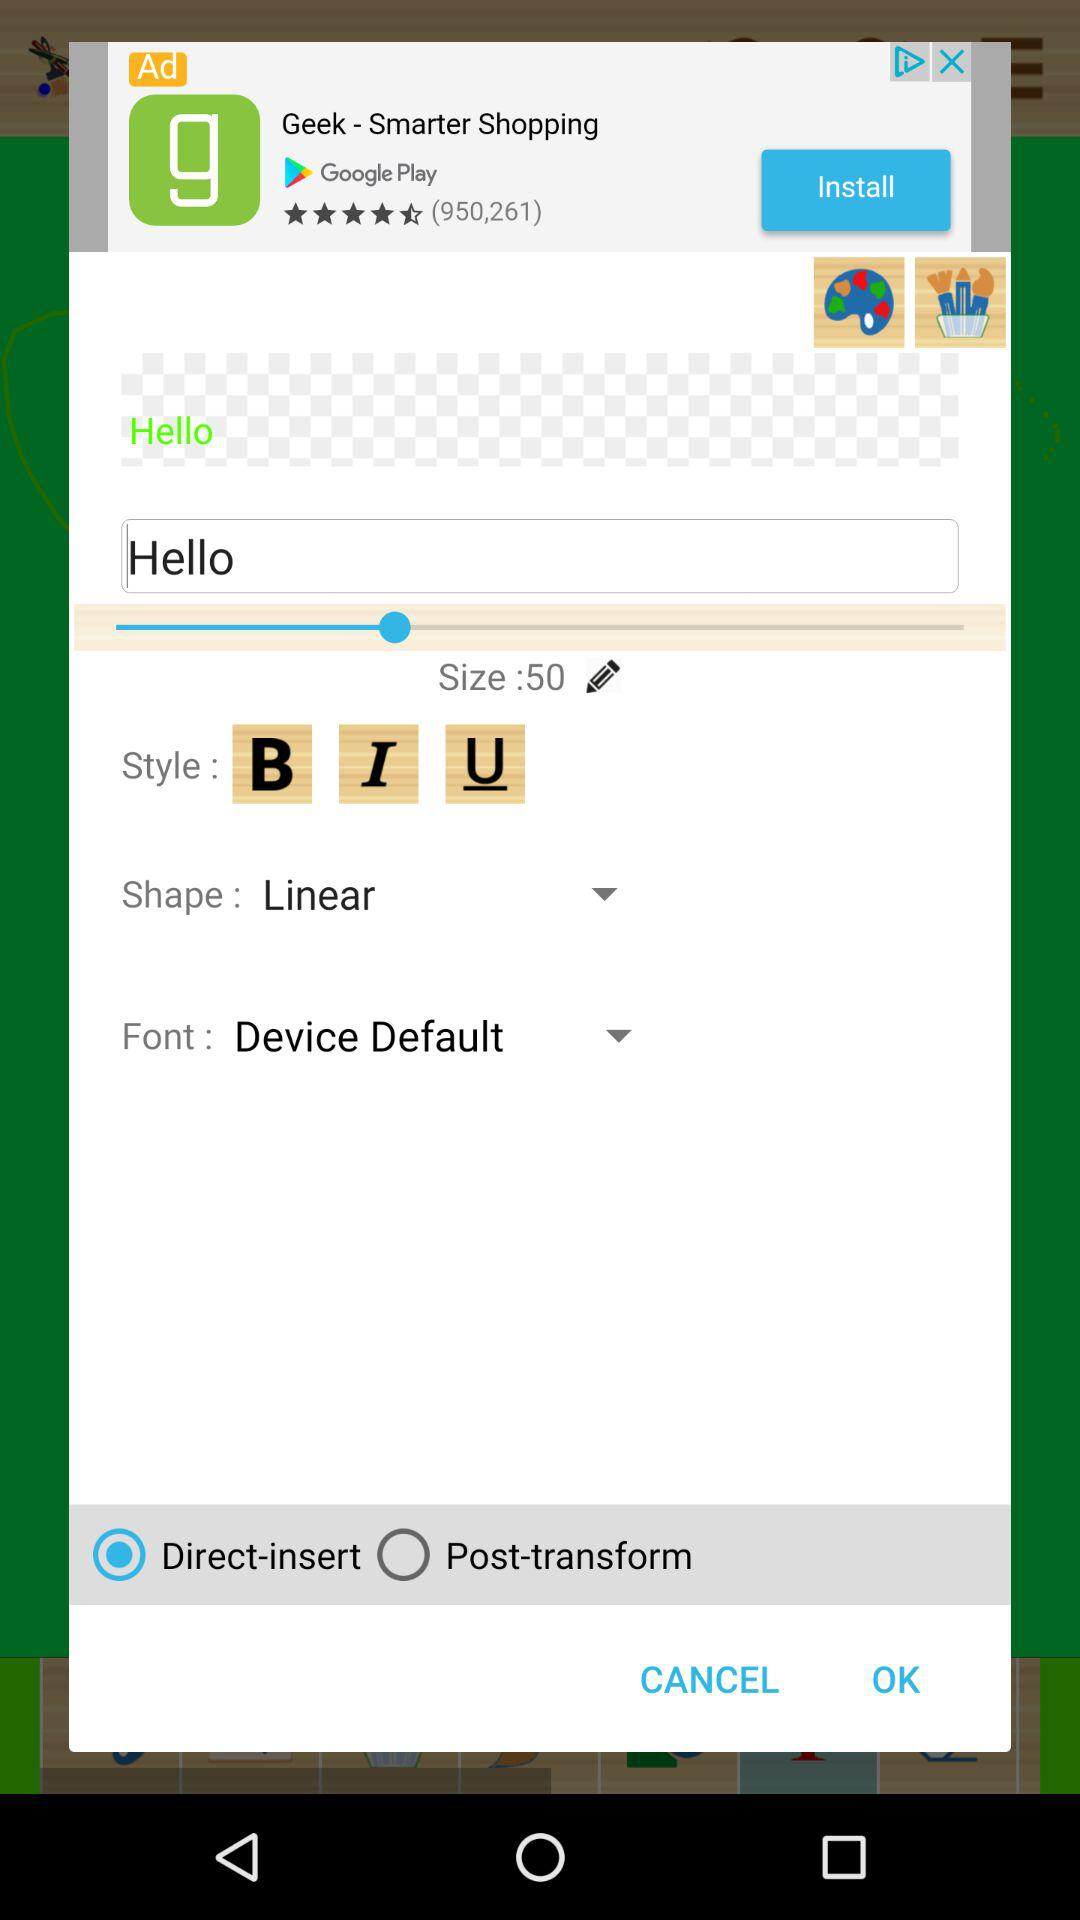Which radio button is selected? The selected radio button is "Direct-insert". 